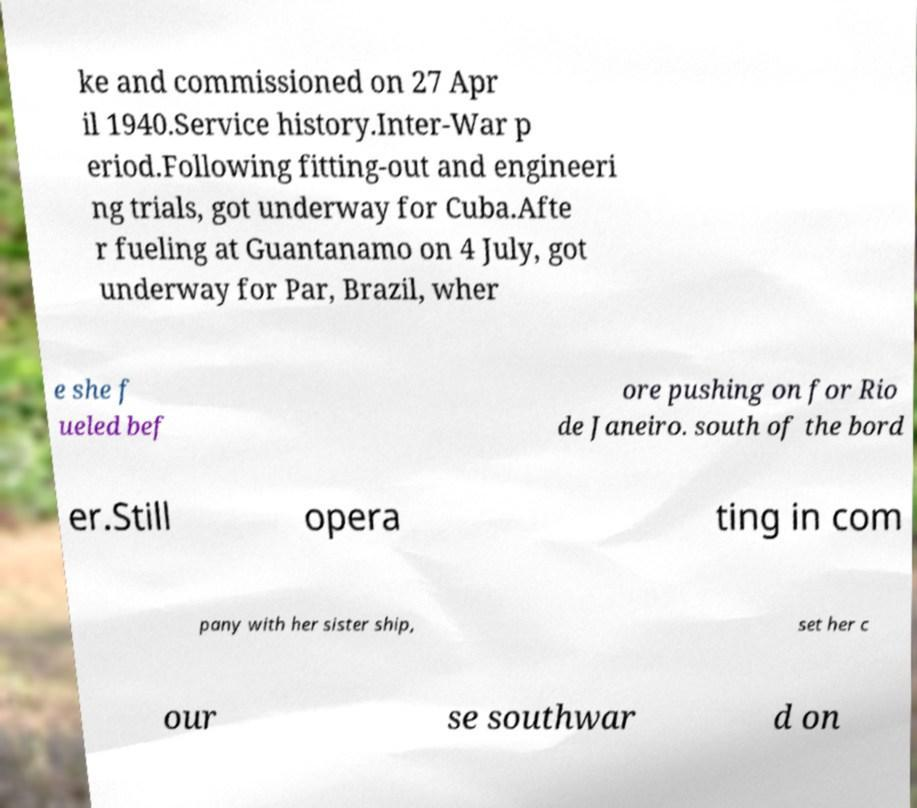For documentation purposes, I need the text within this image transcribed. Could you provide that? ke and commissioned on 27 Apr il 1940.Service history.Inter-War p eriod.Following fitting-out and engineeri ng trials, got underway for Cuba.Afte r fueling at Guantanamo on 4 July, got underway for Par, Brazil, wher e she f ueled bef ore pushing on for Rio de Janeiro. south of the bord er.Still opera ting in com pany with her sister ship, set her c our se southwar d on 